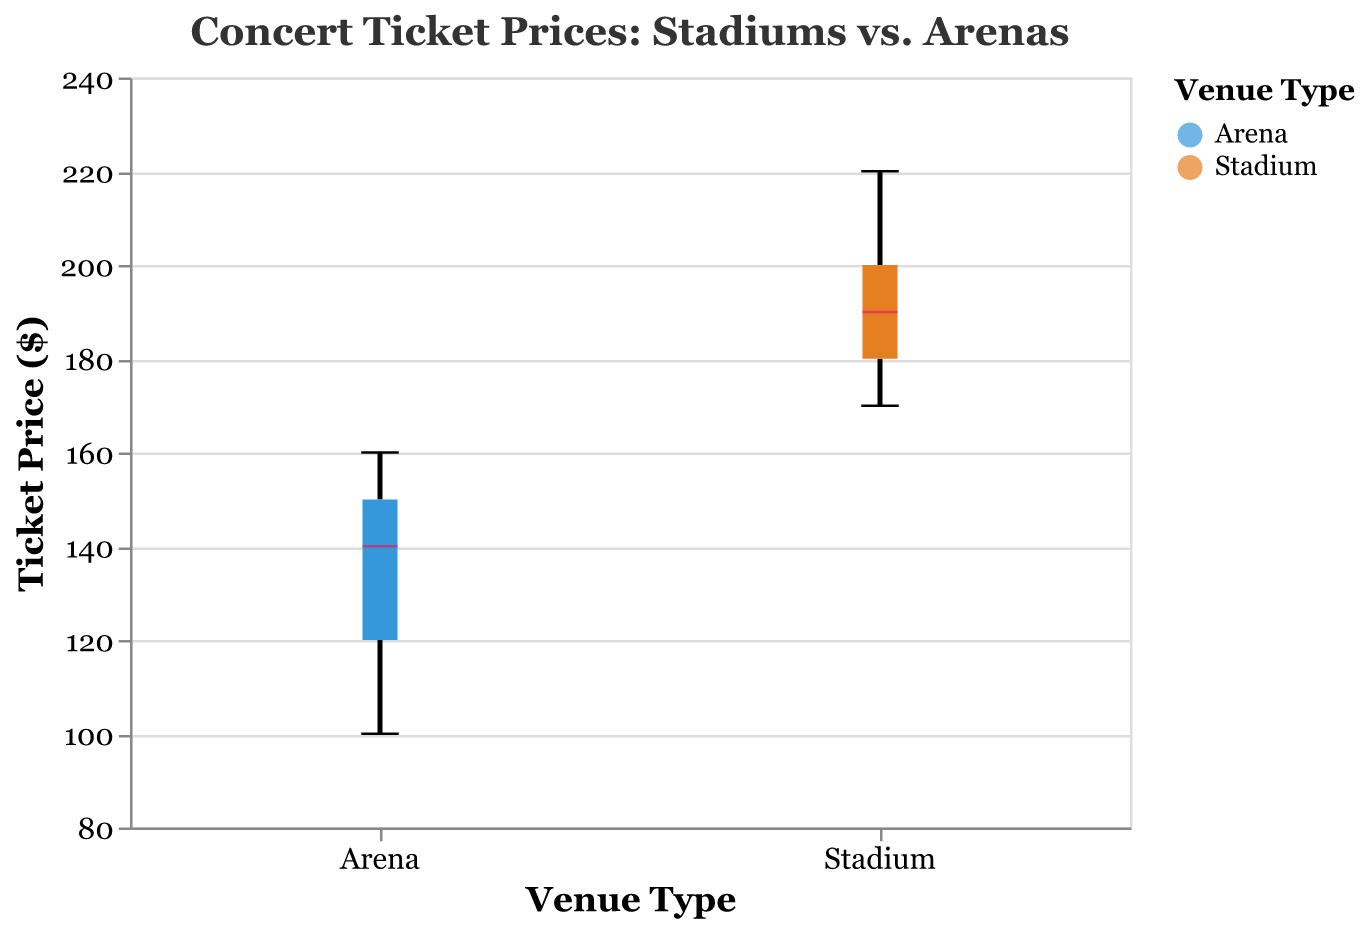What is the title of the figure? The title of the figure is typically displayed at the top center of the chart in larger font size. It indicates what the figure is about.
Answer: Concert Ticket Prices: Stadiums vs. Arenas What is the range of ticket prices displayed on the y-axis? The y-axis label titled "Ticket Price ($)" shows the scale of prices that ranges from minimum to maximum values. The specified scale in the code is from 80 to 240.
Answer: 80 to 240 Which venue type has a higher median concert ticket price? The median is represented by a different color in the box plot, typically a prominent line within each box. By comparing these centrally located lines between the Arena and Stadium, the Stadium has a higher median ticket price.
Answer: Stadium What are the colors used to represent Arenas and Stadiums in the figure? The color blue is used for Arenas and orange for Stadiums. These colors categorize the two venue types visually and consistently in the figure.
Answer: Blue for Arenas, Orange for Stadiums Which venue type has a wider spread of ticket prices? The spread, or variability, of ticket prices is represented by the length between the top and bottom of the box and the whiskers in the box plot. Comparing the length of these elements, Stadiums show a wider spread.
Answer: Stadiums What is the highest ticket price for Stadiums? To find the highest ticket price, look at the top whisker or the highest data point within the Stadium group in the box plot. The top-most point reaches 220.
Answer: 220 What is the lowest ticket price for Arenas? To identify the lowest ticket price, observe the bottom whisker or the lowest data point within the Arena group in the box plot. The lowest value touches 100.
Answer: 100 Compare the medians of both venue types. By how much does the median price for Stadiums exceed that for Arenas? The median values are represented by the distinctive lines within each box. The median for Stadiums can be seen as 185, and for Arenas, it is approximately 140. Subtract the Arena's median from the Stadium's median: 185 - 140 = 45.
Answer: 45 Which venue type has higher variability in ticket prices, based on the interquartile range (IQR)? The IQR is the range between the top and bottom of the box itself, representing the middle 50% of data points. By visually inspecting the boxes, Stadiums have a taller box, indicating more variability.
Answer: Stadiums Explain how the box plot helps visualize the distribution of ticket prices for the two venue types. The box plot provides a clear summary of the distribution, including median, quartiles, and minimum and maximum values. It represents variability through IQR and whiskers and shows any potential outliers. This helps in understanding how ticket prices vary and comparing distributions between Arenas and Stadiums.
Answer: Summarizes distribution, variability, comparison 